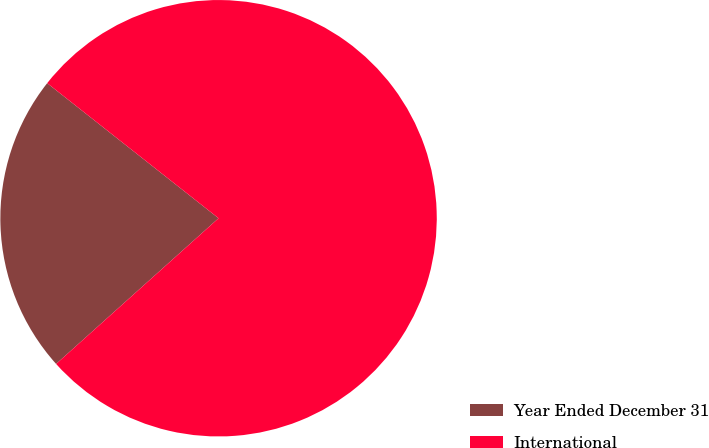<chart> <loc_0><loc_0><loc_500><loc_500><pie_chart><fcel>Year Ended December 31<fcel>International<nl><fcel>22.26%<fcel>77.74%<nl></chart> 